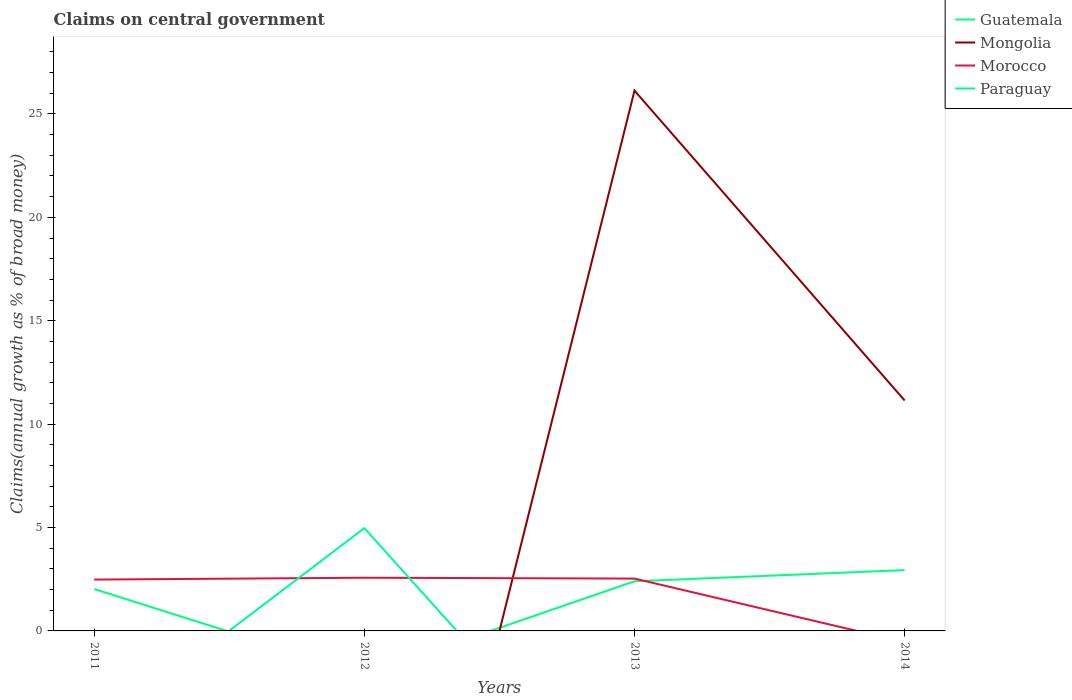How many different coloured lines are there?
Your answer should be very brief. 4. Across all years, what is the maximum percentage of broad money claimed on centeral government in Morocco?
Give a very brief answer. 0. What is the total percentage of broad money claimed on centeral government in Guatemala in the graph?
Offer a very short reply. -0.92. What is the difference between the highest and the second highest percentage of broad money claimed on centeral government in Paraguay?
Offer a terse response. 4.97. How many lines are there?
Keep it short and to the point. 4. How many years are there in the graph?
Offer a very short reply. 4. What is the difference between two consecutive major ticks on the Y-axis?
Your response must be concise. 5. Does the graph contain any zero values?
Offer a very short reply. Yes. Does the graph contain grids?
Your answer should be very brief. No. How many legend labels are there?
Offer a terse response. 4. How are the legend labels stacked?
Your answer should be compact. Vertical. What is the title of the graph?
Ensure brevity in your answer.  Claims on central government. Does "Liberia" appear as one of the legend labels in the graph?
Keep it short and to the point. No. What is the label or title of the X-axis?
Your answer should be very brief. Years. What is the label or title of the Y-axis?
Provide a short and direct response. Claims(annual growth as % of broad money). What is the Claims(annual growth as % of broad money) in Guatemala in 2011?
Your answer should be compact. 2.03. What is the Claims(annual growth as % of broad money) of Morocco in 2011?
Make the answer very short. 2.48. What is the Claims(annual growth as % of broad money) of Mongolia in 2012?
Offer a very short reply. 0. What is the Claims(annual growth as % of broad money) of Morocco in 2012?
Provide a short and direct response. 2.57. What is the Claims(annual growth as % of broad money) in Paraguay in 2012?
Keep it short and to the point. 4.97. What is the Claims(annual growth as % of broad money) of Guatemala in 2013?
Make the answer very short. 2.4. What is the Claims(annual growth as % of broad money) in Mongolia in 2013?
Provide a succinct answer. 26.13. What is the Claims(annual growth as % of broad money) in Morocco in 2013?
Your response must be concise. 2.53. What is the Claims(annual growth as % of broad money) in Paraguay in 2013?
Give a very brief answer. 0. What is the Claims(annual growth as % of broad money) in Guatemala in 2014?
Offer a terse response. 2.94. What is the Claims(annual growth as % of broad money) of Mongolia in 2014?
Provide a short and direct response. 11.14. What is the Claims(annual growth as % of broad money) in Morocco in 2014?
Provide a succinct answer. 0. What is the Claims(annual growth as % of broad money) in Paraguay in 2014?
Your answer should be very brief. 0. Across all years, what is the maximum Claims(annual growth as % of broad money) of Guatemala?
Provide a succinct answer. 2.94. Across all years, what is the maximum Claims(annual growth as % of broad money) of Mongolia?
Keep it short and to the point. 26.13. Across all years, what is the maximum Claims(annual growth as % of broad money) of Morocco?
Offer a terse response. 2.57. Across all years, what is the maximum Claims(annual growth as % of broad money) of Paraguay?
Ensure brevity in your answer.  4.97. Across all years, what is the minimum Claims(annual growth as % of broad money) of Paraguay?
Your answer should be compact. 0. What is the total Claims(annual growth as % of broad money) in Guatemala in the graph?
Your answer should be compact. 7.37. What is the total Claims(annual growth as % of broad money) in Mongolia in the graph?
Give a very brief answer. 37.27. What is the total Claims(annual growth as % of broad money) in Morocco in the graph?
Provide a short and direct response. 7.59. What is the total Claims(annual growth as % of broad money) of Paraguay in the graph?
Offer a terse response. 4.97. What is the difference between the Claims(annual growth as % of broad money) in Morocco in 2011 and that in 2012?
Your response must be concise. -0.09. What is the difference between the Claims(annual growth as % of broad money) in Guatemala in 2011 and that in 2013?
Offer a terse response. -0.38. What is the difference between the Claims(annual growth as % of broad money) in Morocco in 2011 and that in 2013?
Provide a short and direct response. -0.05. What is the difference between the Claims(annual growth as % of broad money) of Guatemala in 2011 and that in 2014?
Provide a short and direct response. -0.92. What is the difference between the Claims(annual growth as % of broad money) of Morocco in 2012 and that in 2013?
Provide a succinct answer. 0.04. What is the difference between the Claims(annual growth as % of broad money) of Guatemala in 2013 and that in 2014?
Provide a short and direct response. -0.54. What is the difference between the Claims(annual growth as % of broad money) of Mongolia in 2013 and that in 2014?
Offer a terse response. 14.98. What is the difference between the Claims(annual growth as % of broad money) in Guatemala in 2011 and the Claims(annual growth as % of broad money) in Morocco in 2012?
Provide a succinct answer. -0.55. What is the difference between the Claims(annual growth as % of broad money) in Guatemala in 2011 and the Claims(annual growth as % of broad money) in Paraguay in 2012?
Offer a terse response. -2.95. What is the difference between the Claims(annual growth as % of broad money) in Morocco in 2011 and the Claims(annual growth as % of broad money) in Paraguay in 2012?
Keep it short and to the point. -2.49. What is the difference between the Claims(annual growth as % of broad money) of Guatemala in 2011 and the Claims(annual growth as % of broad money) of Mongolia in 2013?
Provide a short and direct response. -24.1. What is the difference between the Claims(annual growth as % of broad money) of Guatemala in 2011 and the Claims(annual growth as % of broad money) of Morocco in 2013?
Keep it short and to the point. -0.51. What is the difference between the Claims(annual growth as % of broad money) of Guatemala in 2011 and the Claims(annual growth as % of broad money) of Mongolia in 2014?
Ensure brevity in your answer.  -9.12. What is the difference between the Claims(annual growth as % of broad money) in Guatemala in 2013 and the Claims(annual growth as % of broad money) in Mongolia in 2014?
Your answer should be compact. -8.74. What is the average Claims(annual growth as % of broad money) in Guatemala per year?
Ensure brevity in your answer.  1.84. What is the average Claims(annual growth as % of broad money) of Mongolia per year?
Your answer should be compact. 9.32. What is the average Claims(annual growth as % of broad money) of Morocco per year?
Ensure brevity in your answer.  1.9. What is the average Claims(annual growth as % of broad money) of Paraguay per year?
Your answer should be compact. 1.24. In the year 2011, what is the difference between the Claims(annual growth as % of broad money) in Guatemala and Claims(annual growth as % of broad money) in Morocco?
Provide a succinct answer. -0.46. In the year 2012, what is the difference between the Claims(annual growth as % of broad money) of Morocco and Claims(annual growth as % of broad money) of Paraguay?
Keep it short and to the point. -2.4. In the year 2013, what is the difference between the Claims(annual growth as % of broad money) of Guatemala and Claims(annual growth as % of broad money) of Mongolia?
Ensure brevity in your answer.  -23.73. In the year 2013, what is the difference between the Claims(annual growth as % of broad money) in Guatemala and Claims(annual growth as % of broad money) in Morocco?
Ensure brevity in your answer.  -0.13. In the year 2013, what is the difference between the Claims(annual growth as % of broad money) of Mongolia and Claims(annual growth as % of broad money) of Morocco?
Your answer should be compact. 23.6. In the year 2014, what is the difference between the Claims(annual growth as % of broad money) of Guatemala and Claims(annual growth as % of broad money) of Mongolia?
Make the answer very short. -8.2. What is the ratio of the Claims(annual growth as % of broad money) of Morocco in 2011 to that in 2012?
Provide a succinct answer. 0.97. What is the ratio of the Claims(annual growth as % of broad money) in Guatemala in 2011 to that in 2013?
Keep it short and to the point. 0.84. What is the ratio of the Claims(annual growth as % of broad money) of Morocco in 2011 to that in 2013?
Your answer should be very brief. 0.98. What is the ratio of the Claims(annual growth as % of broad money) in Guatemala in 2011 to that in 2014?
Keep it short and to the point. 0.69. What is the ratio of the Claims(annual growth as % of broad money) in Morocco in 2012 to that in 2013?
Ensure brevity in your answer.  1.02. What is the ratio of the Claims(annual growth as % of broad money) in Guatemala in 2013 to that in 2014?
Make the answer very short. 0.82. What is the ratio of the Claims(annual growth as % of broad money) of Mongolia in 2013 to that in 2014?
Keep it short and to the point. 2.34. What is the difference between the highest and the second highest Claims(annual growth as % of broad money) of Guatemala?
Keep it short and to the point. 0.54. What is the difference between the highest and the second highest Claims(annual growth as % of broad money) of Morocco?
Your response must be concise. 0.04. What is the difference between the highest and the lowest Claims(annual growth as % of broad money) of Guatemala?
Give a very brief answer. 2.94. What is the difference between the highest and the lowest Claims(annual growth as % of broad money) of Mongolia?
Make the answer very short. 26.13. What is the difference between the highest and the lowest Claims(annual growth as % of broad money) of Morocco?
Your answer should be very brief. 2.57. What is the difference between the highest and the lowest Claims(annual growth as % of broad money) in Paraguay?
Your response must be concise. 4.97. 